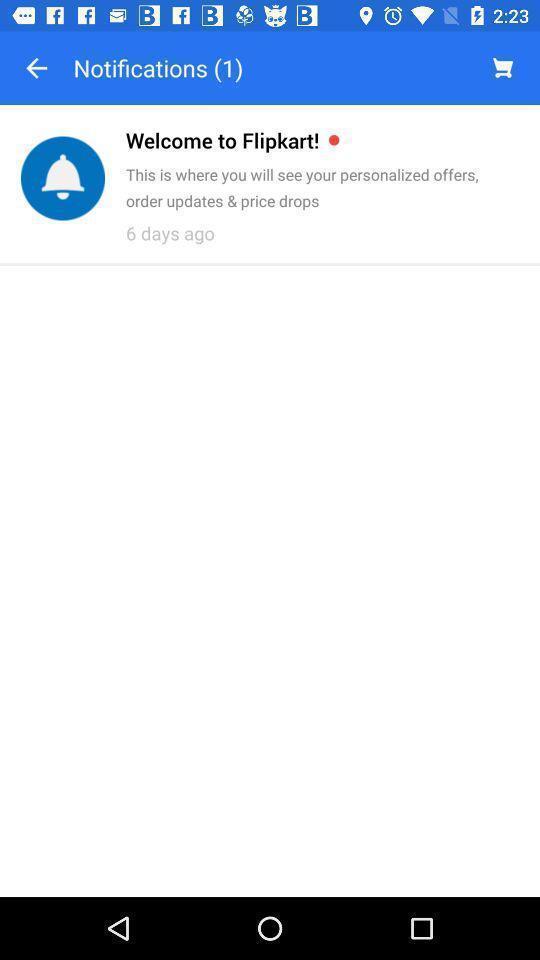What is the overall content of this screenshot? Welcome notification. 